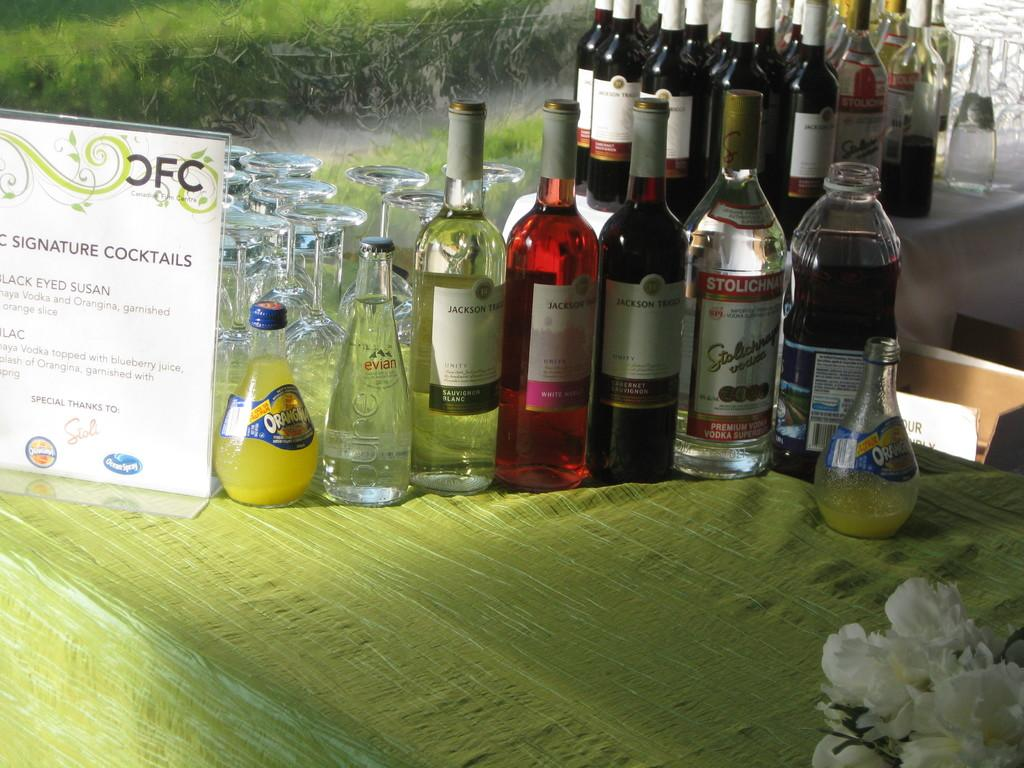<image>
Give a short and clear explanation of the subsequent image. A sign for OFC Signature Cocktails is on a table with many bottles of alcohol. 